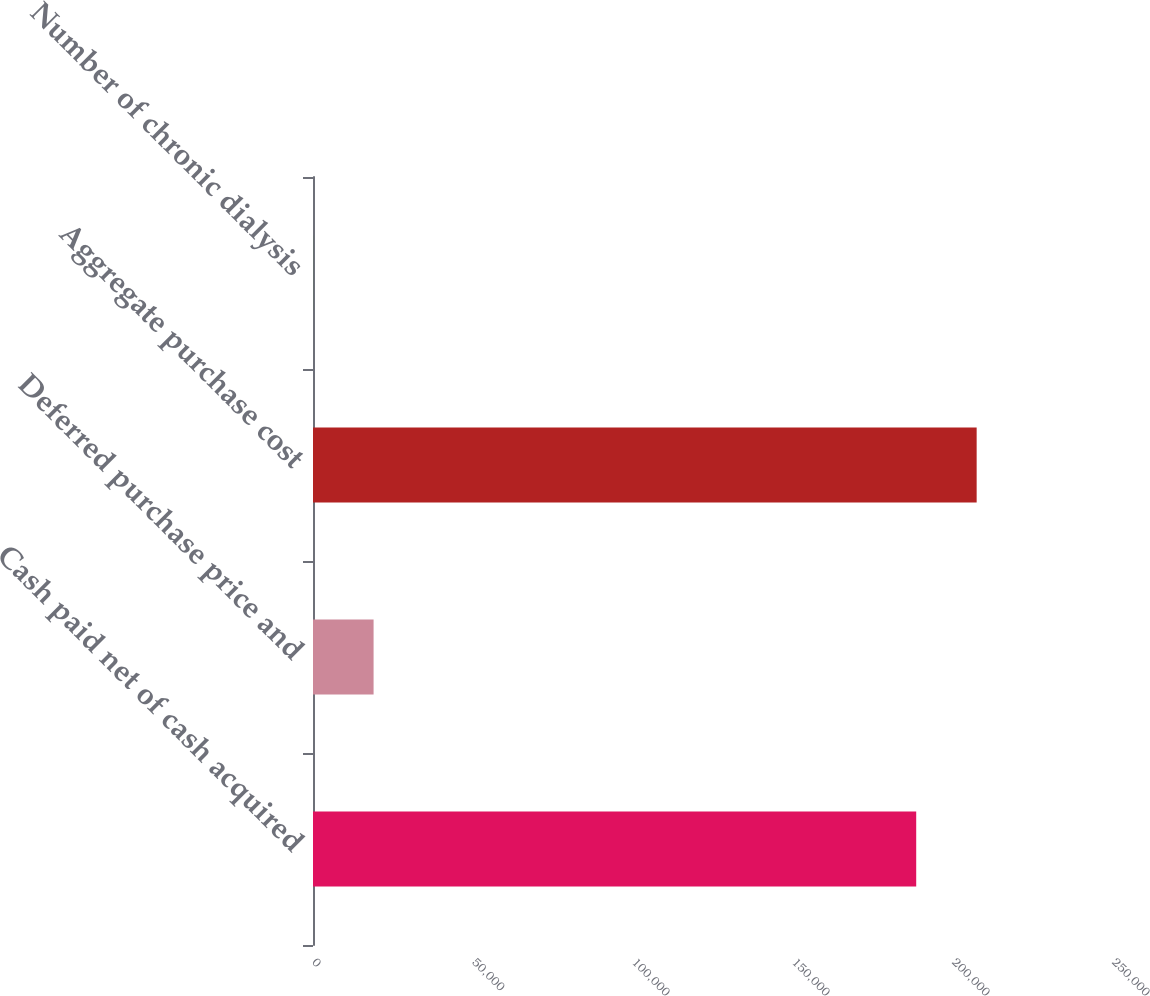Convert chart to OTSL. <chart><loc_0><loc_0><loc_500><loc_500><bar_chart><fcel>Cash paid net of cash acquired<fcel>Deferred purchase price and<fcel>Aggregate purchase cost<fcel>Number of chronic dialysis<nl><fcel>188502<fcel>18932<fcel>207393<fcel>41<nl></chart> 